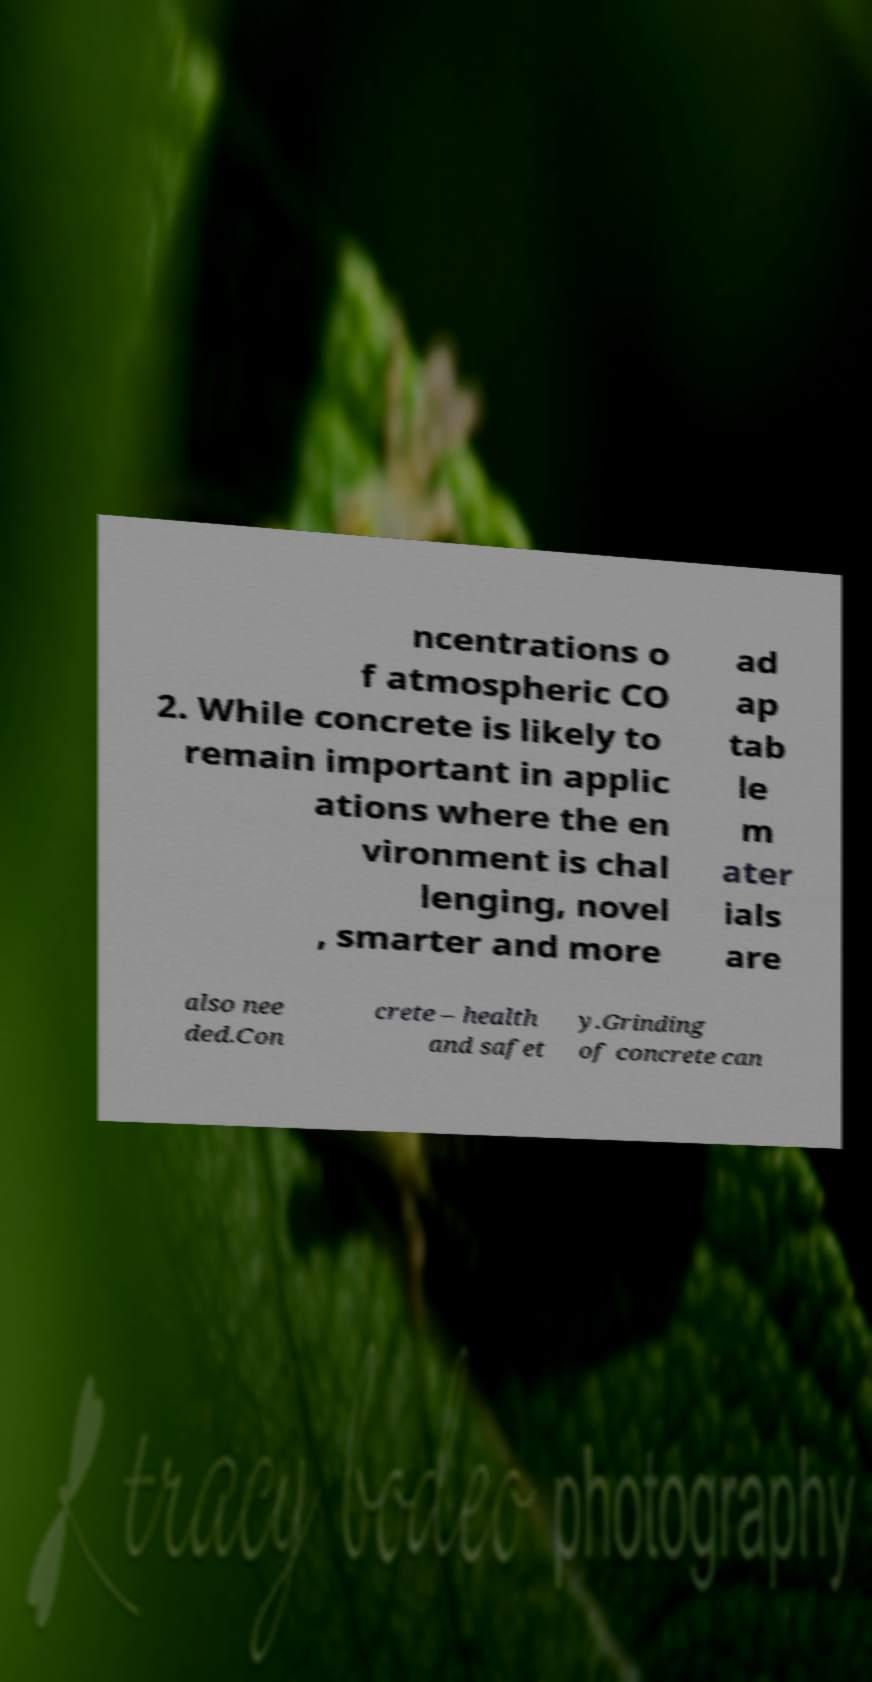I need the written content from this picture converted into text. Can you do that? ncentrations o f atmospheric CO 2. While concrete is likely to remain important in applic ations where the en vironment is chal lenging, novel , smarter and more ad ap tab le m ater ials are also nee ded.Con crete – health and safet y.Grinding of concrete can 